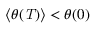Convert formula to latex. <formula><loc_0><loc_0><loc_500><loc_500>\langle \theta ( T ) \rangle < \theta ( 0 )</formula> 